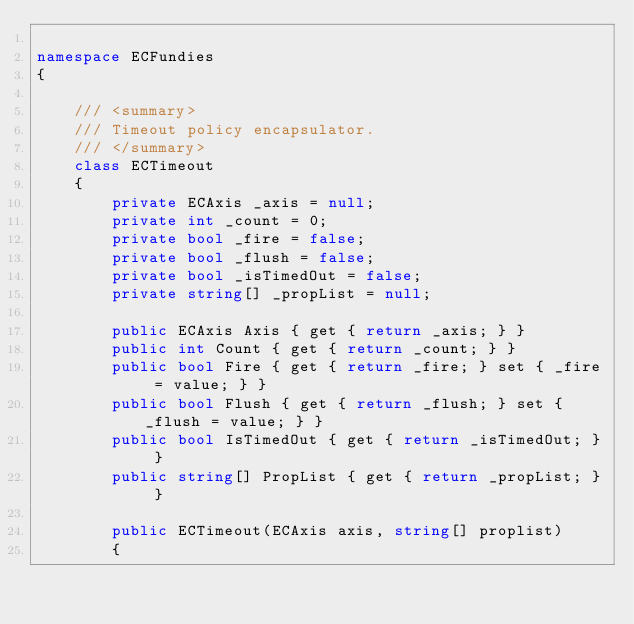Convert code to text. <code><loc_0><loc_0><loc_500><loc_500><_C#_>
namespace ECFundies
{

    /// <summary>
    /// Timeout policy encapsulator.
    /// </summary>
    class ECTimeout
    {
        private ECAxis _axis = null;
        private int _count = 0;
        private bool _fire = false;
        private bool _flush = false;
        private bool _isTimedOut = false;
        private string[] _propList = null;

        public ECAxis Axis { get { return _axis; } }
        public int Count { get { return _count; } }
        public bool Fire { get { return _fire; } set { _fire = value; } }
        public bool Flush { get { return _flush; } set { _flush = value; } }
        public bool IsTimedOut { get { return _isTimedOut; } }
        public string[] PropList { get { return _propList; } }
        
        public ECTimeout(ECAxis axis, string[] proplist)
        {</code> 